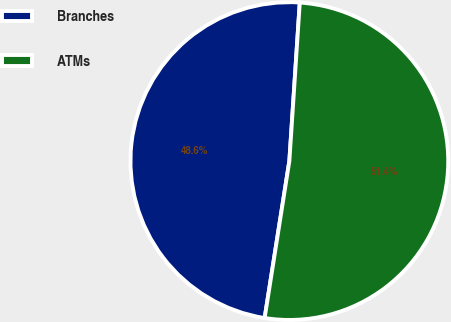<chart> <loc_0><loc_0><loc_500><loc_500><pie_chart><fcel>Branches<fcel>ATMs<nl><fcel>48.56%<fcel>51.44%<nl></chart> 